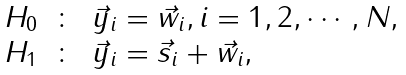Convert formula to latex. <formula><loc_0><loc_0><loc_500><loc_500>\begin{array} { l c l } H _ { 0 } & \colon & \vec { y } _ { i } = \vec { w } _ { i } , i = 1 , 2 , \cdots , N , \\ H _ { 1 } & \colon & \vec { y } _ { i } = \vec { s } _ { i } + \vec { w } _ { i } , \\ \end{array}</formula> 